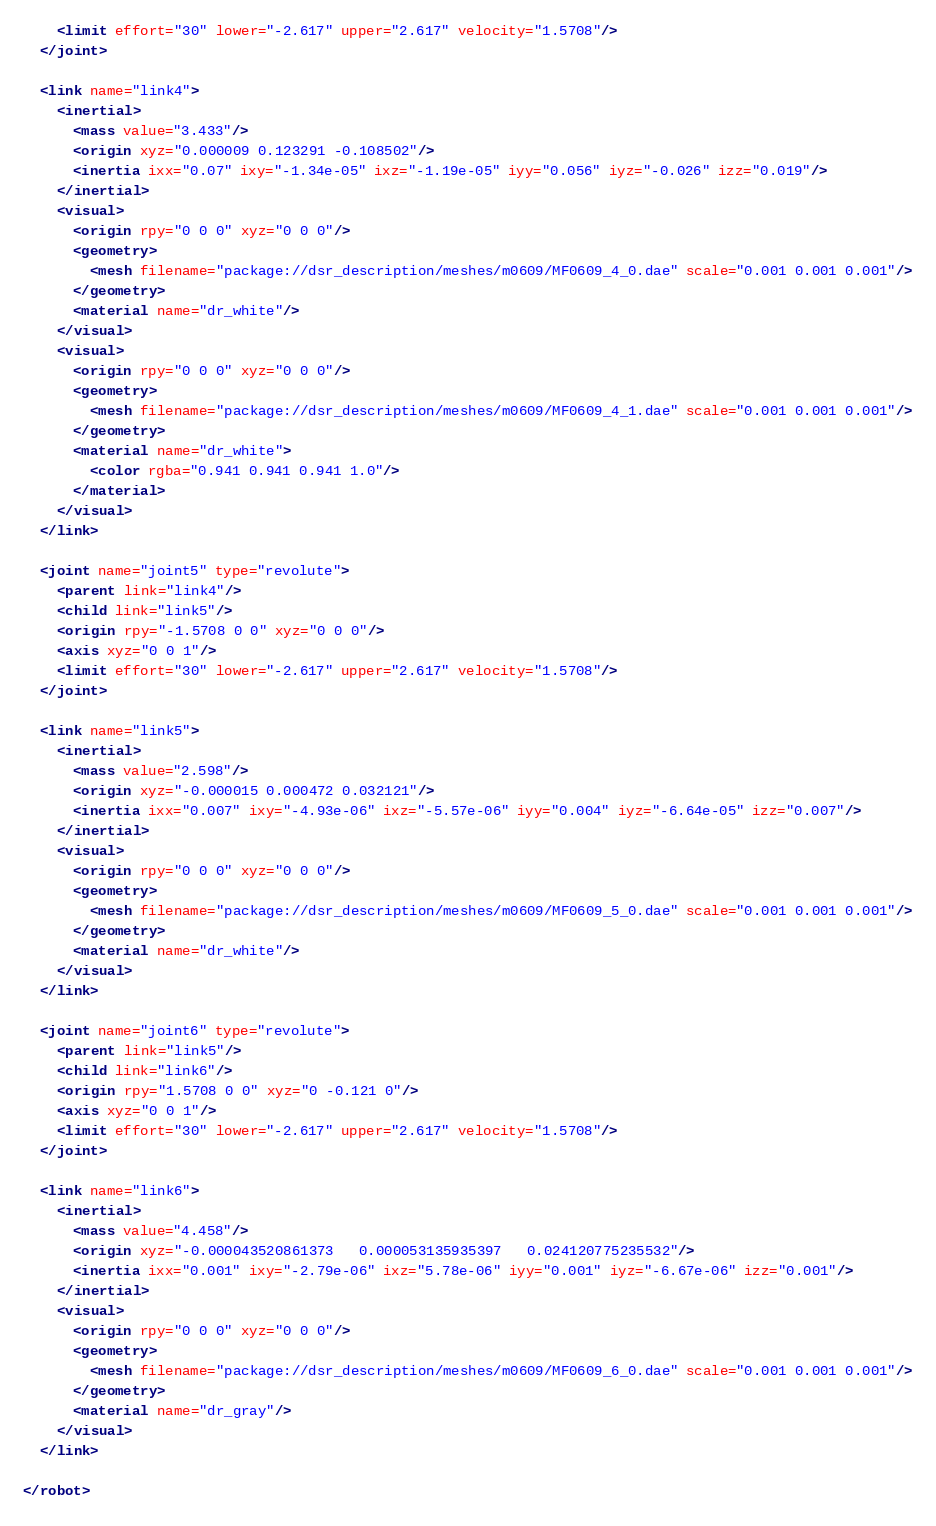Convert code to text. <code><loc_0><loc_0><loc_500><loc_500><_XML_>    <limit effort="30" lower="-2.617" upper="2.617" velocity="1.5708"/>
  </joint>
  
  <link name="link4">
	<inertial>
	  <mass value="3.433"/>
	  <origin xyz="0.000009 0.123291 -0.108502"/>
      <inertia ixx="0.07" ixy="-1.34e-05" ixz="-1.19e-05" iyy="0.056" iyz="-0.026" izz="0.019"/>
    </inertial>
    <visual>
      <origin rpy="0 0 0" xyz="0 0 0"/>
      <geometry>     
		<mesh filename="package://dsr_description/meshes/m0609/MF0609_4_0.dae" scale="0.001 0.001 0.001"/>
      </geometry>
      <material name="dr_white"/>
    </visual>
    <visual>
      <origin rpy="0 0 0" xyz="0 0 0"/>
      <geometry>     
		<mesh filename="package://dsr_description/meshes/m0609/MF0609_4_1.dae" scale="0.001 0.001 0.001"/>
      </geometry>
      <material name="dr_white">
        <color rgba="0.941 0.941 0.941 1.0"/>
      </material>
    </visual>
  </link>

  <joint name="joint5" type="revolute">
    <parent link="link4"/>
    <child link="link5"/>
    <origin rpy="-1.5708 0 0" xyz="0 0 0"/>
    <axis xyz="0 0 1"/>
    <limit effort="30" lower="-2.617" upper="2.617" velocity="1.5708"/>
  </joint>
  
  <link name="link5">
	<inertial>
	  <mass value="2.598"/>
	  <origin xyz="-0.000015 0.000472 0.032121"/>
      <inertia ixx="0.007" ixy="-4.93e-06" ixz="-5.57e-06" iyy="0.004" iyz="-6.64e-05" izz="0.007"/>
    </inertial>
    <visual>
      <origin rpy="0 0 0" xyz="0 0 0"/>
      <geometry>     
		<mesh filename="package://dsr_description/meshes/m0609/MF0609_5_0.dae" scale="0.001 0.001 0.001"/>
      </geometry>
      <material name="dr_white"/>
    </visual>
  </link>

  <joint name="joint6" type="revolute">
    <parent link="link5"/>
    <child link="link6"/>
    <origin rpy="1.5708 0 0" xyz="0 -0.121 0"/>
    <axis xyz="0 0 1"/>
    <limit effort="30" lower="-2.617" upper="2.617" velocity="1.5708"/>
  </joint>
  
  <link name="link6">
	<inertial>
	  <mass value="4.458"/>
	  <origin xyz="-0.000043520861373   0.000053135935397   0.024120775235532"/>
      <inertia ixx="0.001" ixy="-2.79e-06" ixz="5.78e-06" iyy="0.001" iyz="-6.67e-06" izz="0.001"/>
    </inertial>
    <visual>
      <origin rpy="0 0 0" xyz="0 0 0"/>
      <geometry>     
		<mesh filename="package://dsr_description/meshes/m0609/MF0609_6_0.dae" scale="0.001 0.001 0.001"/>
      </geometry>
      <material name="dr_gray"/>
    </visual>
  </link>
  
</robot>
</code> 